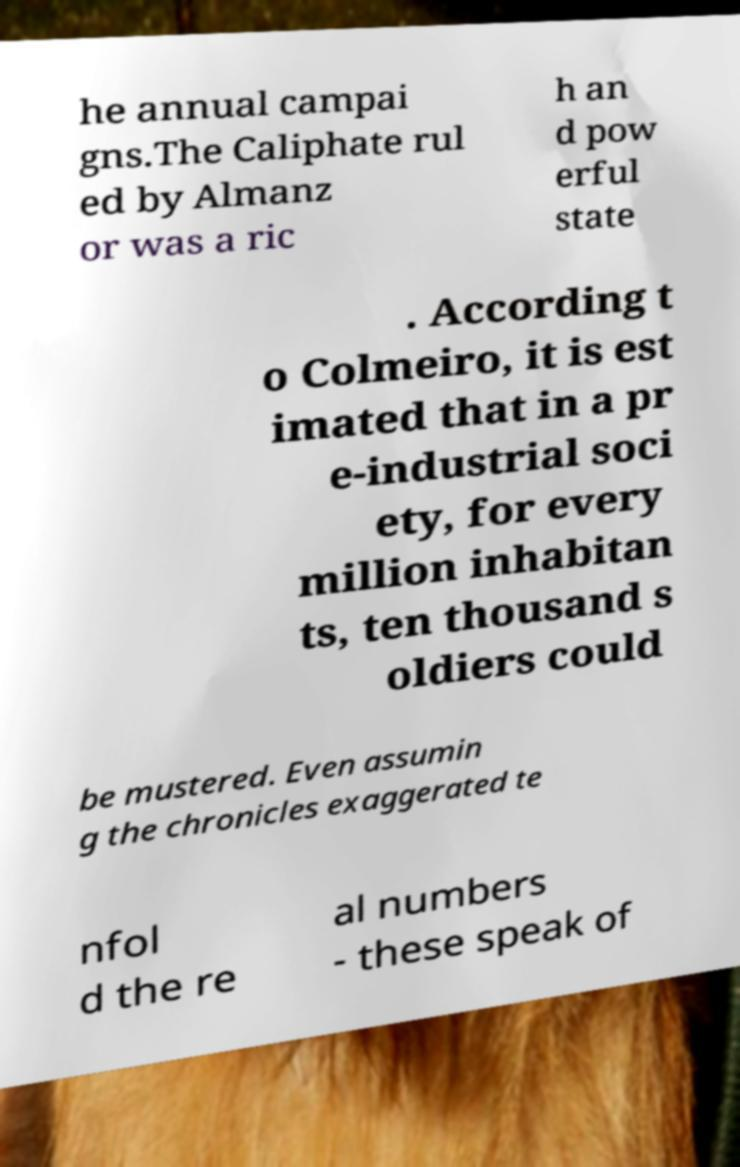For documentation purposes, I need the text within this image transcribed. Could you provide that? he annual campai gns.The Caliphate rul ed by Almanz or was a ric h an d pow erful state . According t o Colmeiro, it is est imated that in a pr e-industrial soci ety, for every million inhabitan ts, ten thousand s oldiers could be mustered. Even assumin g the chronicles exaggerated te nfol d the re al numbers - these speak of 